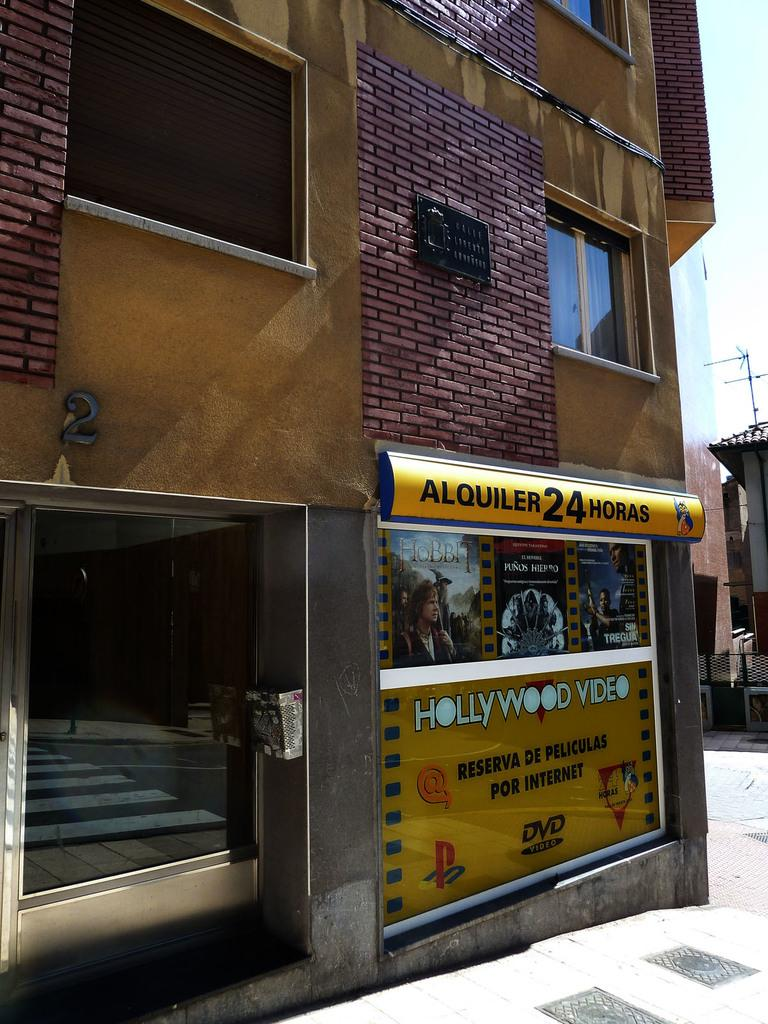Provide a one-sentence caption for the provided image. A Hollywood video that is located outside somewhere. 